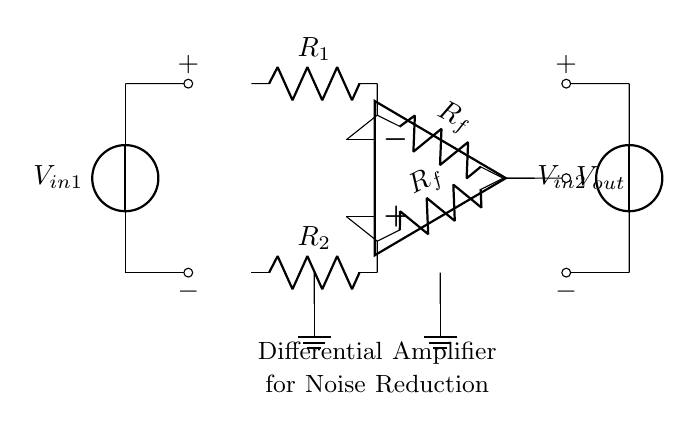What is the output voltage in the circuit? The output voltage is represented as Vout in the circuit diagram, which is connected to the output of the operational amplifier.
Answer: Vout What type of amplifier is shown in the diagram? The circuit is identified as a differential amplifier, as indicated by the label at the bottom, specifically designed for enhancing the difference between two input signals.
Answer: Differential amplifier What are the resistors labeled in the circuit? The resistors in the circuit are labeled as R1 and R2 for the input, and Rf for the feedback, which are essential for setting the gain of the amplifier.
Answer: R1, R2, Rf How many input voltage sources are present in this circuit? There are two voltage sources, V_in1 and V_in2, connected to the input terminals of the differential amplifier, allowing it to process two signals.
Answer: Two What is the function of the feedback resistor in this circuit? The feedback resistor Rf controls the gain of the differential amplifier, impacting how much the output is influenced by the difference in input voltages.
Answer: Control gain Where are the ground connections located on the diagram? The grounds are marked at the bottom in the circuit diagram, ensuring that the reference point for the voltages is established and the circuit operates correctly.
Answer: At the bottom What is the purpose of this circuit in signal processing applications? This differential amplifier circuit is used for noise reduction, effectively amplifying the desired signal while minimizing noise and interference from common sources.
Answer: Noise reduction 